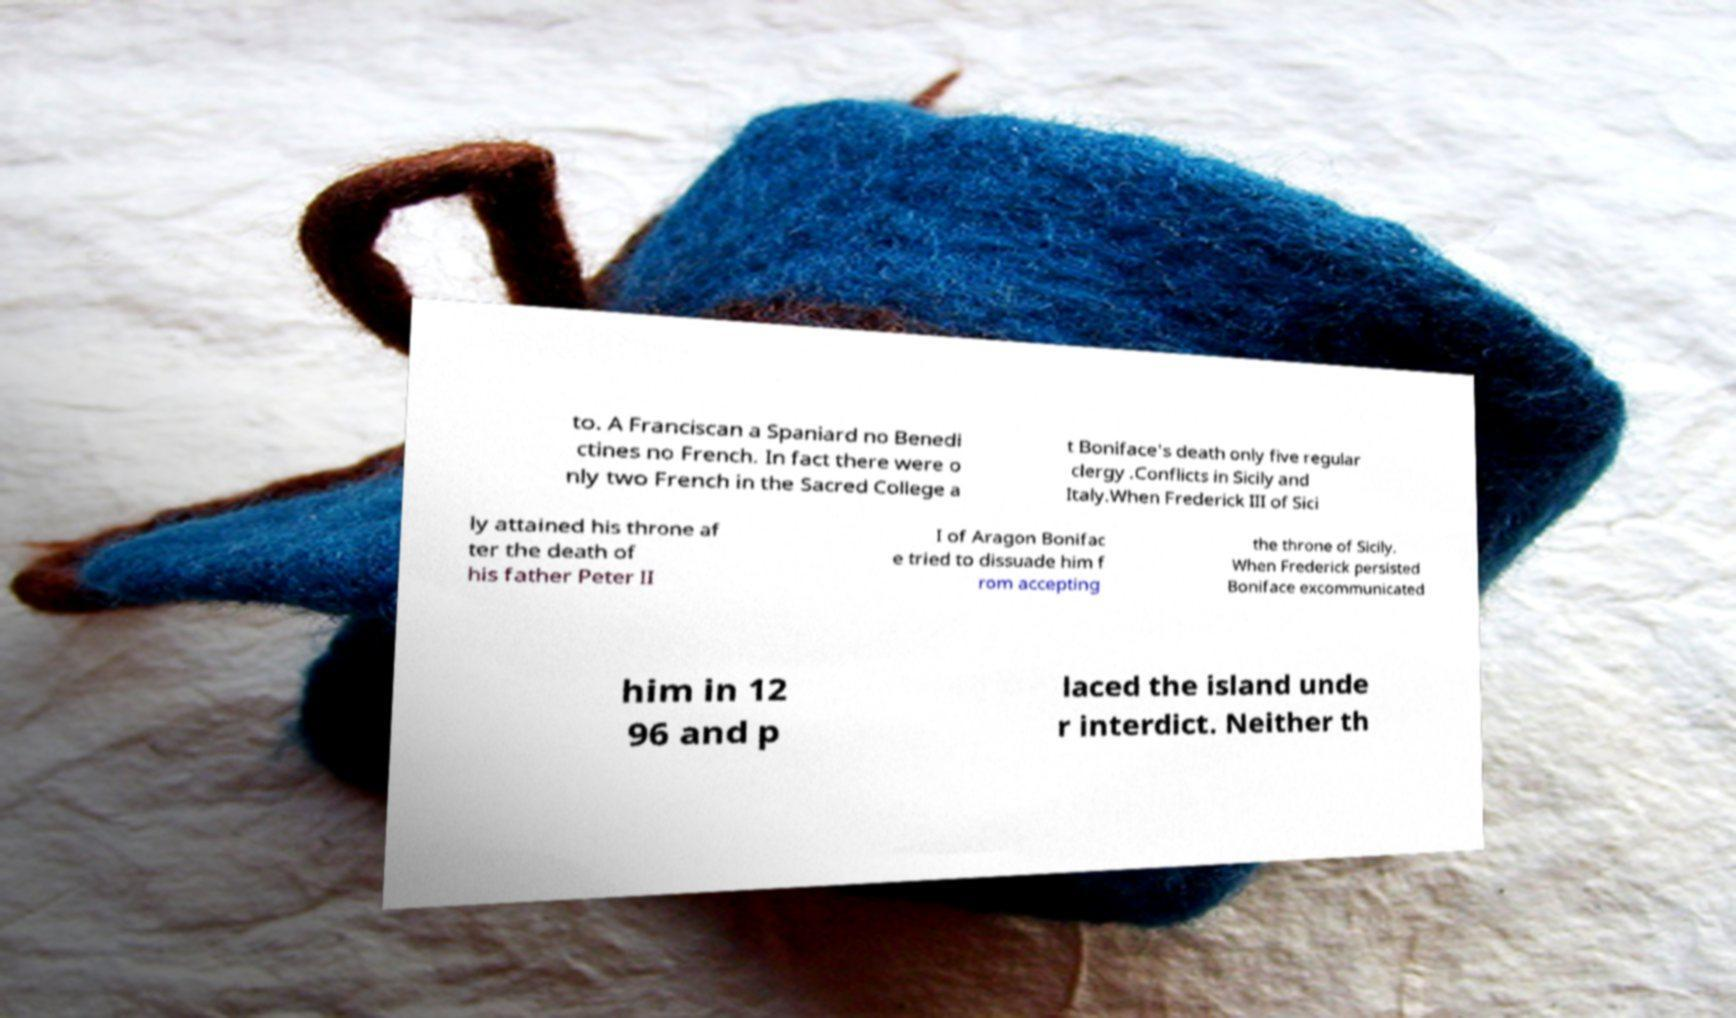Please read and relay the text visible in this image. What does it say? to. A Franciscan a Spaniard no Benedi ctines no French. In fact there were o nly two French in the Sacred College a t Boniface's death only five regular clergy .Conflicts in Sicily and Italy.When Frederick III of Sici ly attained his throne af ter the death of his father Peter II I of Aragon Bonifac e tried to dissuade him f rom accepting the throne of Sicily. When Frederick persisted Boniface excommunicated him in 12 96 and p laced the island unde r interdict. Neither th 